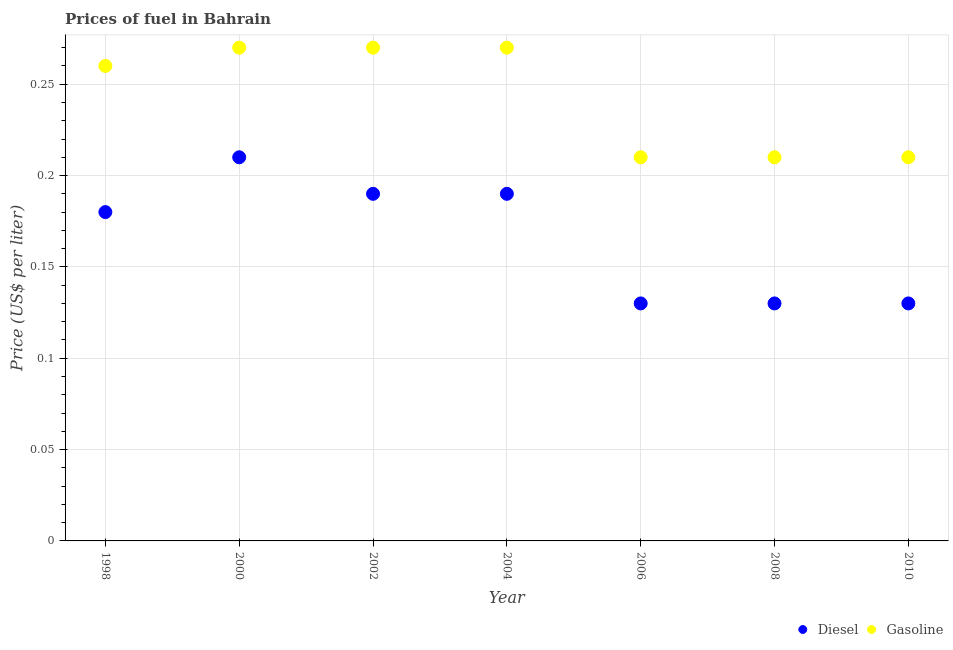Is the number of dotlines equal to the number of legend labels?
Offer a terse response. Yes. What is the diesel price in 2000?
Offer a terse response. 0.21. Across all years, what is the maximum diesel price?
Provide a short and direct response. 0.21. Across all years, what is the minimum diesel price?
Offer a very short reply. 0.13. In which year was the gasoline price maximum?
Your answer should be very brief. 2000. In which year was the gasoline price minimum?
Provide a short and direct response. 2006. What is the total diesel price in the graph?
Give a very brief answer. 1.16. What is the difference between the gasoline price in 2006 and the diesel price in 2008?
Offer a terse response. 0.08. What is the average diesel price per year?
Provide a succinct answer. 0.17. In the year 2006, what is the difference between the diesel price and gasoline price?
Keep it short and to the point. -0.08. In how many years, is the gasoline price greater than 0.04 US$ per litre?
Provide a succinct answer. 7. What is the ratio of the gasoline price in 2000 to that in 2010?
Keep it short and to the point. 1.29. Is the diesel price in 2004 less than that in 2010?
Give a very brief answer. No. Is the difference between the diesel price in 2006 and 2010 greater than the difference between the gasoline price in 2006 and 2010?
Your response must be concise. No. What is the difference between the highest and the second highest diesel price?
Your answer should be very brief. 0.02. What is the difference between the highest and the lowest diesel price?
Offer a terse response. 0.08. In how many years, is the diesel price greater than the average diesel price taken over all years?
Provide a short and direct response. 4. Does the gasoline price monotonically increase over the years?
Provide a short and direct response. No. Is the diesel price strictly greater than the gasoline price over the years?
Provide a short and direct response. No. Is the gasoline price strictly less than the diesel price over the years?
Ensure brevity in your answer.  No. How many dotlines are there?
Give a very brief answer. 2. How many years are there in the graph?
Ensure brevity in your answer.  7. What is the difference between two consecutive major ticks on the Y-axis?
Keep it short and to the point. 0.05. Are the values on the major ticks of Y-axis written in scientific E-notation?
Keep it short and to the point. No. Does the graph contain any zero values?
Provide a short and direct response. No. Does the graph contain grids?
Your answer should be compact. Yes. Where does the legend appear in the graph?
Keep it short and to the point. Bottom right. What is the title of the graph?
Give a very brief answer. Prices of fuel in Bahrain. Does "Age 65(male)" appear as one of the legend labels in the graph?
Offer a very short reply. No. What is the label or title of the Y-axis?
Offer a terse response. Price (US$ per liter). What is the Price (US$ per liter) in Diesel in 1998?
Offer a terse response. 0.18. What is the Price (US$ per liter) in Gasoline in 1998?
Ensure brevity in your answer.  0.26. What is the Price (US$ per liter) of Diesel in 2000?
Your answer should be compact. 0.21. What is the Price (US$ per liter) in Gasoline in 2000?
Give a very brief answer. 0.27. What is the Price (US$ per liter) of Diesel in 2002?
Your response must be concise. 0.19. What is the Price (US$ per liter) in Gasoline in 2002?
Give a very brief answer. 0.27. What is the Price (US$ per liter) of Diesel in 2004?
Your response must be concise. 0.19. What is the Price (US$ per liter) in Gasoline in 2004?
Your response must be concise. 0.27. What is the Price (US$ per liter) of Diesel in 2006?
Provide a short and direct response. 0.13. What is the Price (US$ per liter) in Gasoline in 2006?
Provide a succinct answer. 0.21. What is the Price (US$ per liter) in Diesel in 2008?
Offer a terse response. 0.13. What is the Price (US$ per liter) of Gasoline in 2008?
Provide a short and direct response. 0.21. What is the Price (US$ per liter) of Diesel in 2010?
Keep it short and to the point. 0.13. What is the Price (US$ per liter) in Gasoline in 2010?
Your answer should be very brief. 0.21. Across all years, what is the maximum Price (US$ per liter) of Diesel?
Your answer should be very brief. 0.21. Across all years, what is the maximum Price (US$ per liter) of Gasoline?
Make the answer very short. 0.27. Across all years, what is the minimum Price (US$ per liter) in Diesel?
Make the answer very short. 0.13. Across all years, what is the minimum Price (US$ per liter) in Gasoline?
Your answer should be compact. 0.21. What is the total Price (US$ per liter) of Diesel in the graph?
Your answer should be very brief. 1.16. What is the total Price (US$ per liter) in Gasoline in the graph?
Ensure brevity in your answer.  1.7. What is the difference between the Price (US$ per liter) of Diesel in 1998 and that in 2000?
Provide a succinct answer. -0.03. What is the difference between the Price (US$ per liter) in Gasoline in 1998 and that in 2000?
Your response must be concise. -0.01. What is the difference between the Price (US$ per liter) in Diesel in 1998 and that in 2002?
Provide a succinct answer. -0.01. What is the difference between the Price (US$ per liter) in Gasoline in 1998 and that in 2002?
Make the answer very short. -0.01. What is the difference between the Price (US$ per liter) in Diesel in 1998 and that in 2004?
Keep it short and to the point. -0.01. What is the difference between the Price (US$ per liter) of Gasoline in 1998 and that in 2004?
Offer a terse response. -0.01. What is the difference between the Price (US$ per liter) in Diesel in 1998 and that in 2006?
Offer a terse response. 0.05. What is the difference between the Price (US$ per liter) of Gasoline in 1998 and that in 2006?
Your response must be concise. 0.05. What is the difference between the Price (US$ per liter) of Diesel in 1998 and that in 2008?
Your response must be concise. 0.05. What is the difference between the Price (US$ per liter) of Gasoline in 1998 and that in 2010?
Your answer should be very brief. 0.05. What is the difference between the Price (US$ per liter) of Diesel in 2000 and that in 2004?
Make the answer very short. 0.02. What is the difference between the Price (US$ per liter) in Diesel in 2000 and that in 2006?
Provide a succinct answer. 0.08. What is the difference between the Price (US$ per liter) of Gasoline in 2000 and that in 2006?
Ensure brevity in your answer.  0.06. What is the difference between the Price (US$ per liter) of Gasoline in 2000 and that in 2008?
Your answer should be very brief. 0.06. What is the difference between the Price (US$ per liter) in Diesel in 2002 and that in 2004?
Give a very brief answer. 0. What is the difference between the Price (US$ per liter) of Gasoline in 2002 and that in 2006?
Ensure brevity in your answer.  0.06. What is the difference between the Price (US$ per liter) of Diesel in 2002 and that in 2010?
Offer a very short reply. 0.06. What is the difference between the Price (US$ per liter) of Diesel in 2004 and that in 2006?
Give a very brief answer. 0.06. What is the difference between the Price (US$ per liter) of Diesel in 2004 and that in 2008?
Your answer should be compact. 0.06. What is the difference between the Price (US$ per liter) in Gasoline in 2004 and that in 2010?
Make the answer very short. 0.06. What is the difference between the Price (US$ per liter) in Diesel in 2006 and that in 2010?
Ensure brevity in your answer.  0. What is the difference between the Price (US$ per liter) of Diesel in 2008 and that in 2010?
Your answer should be compact. 0. What is the difference between the Price (US$ per liter) of Gasoline in 2008 and that in 2010?
Offer a very short reply. 0. What is the difference between the Price (US$ per liter) in Diesel in 1998 and the Price (US$ per liter) in Gasoline in 2000?
Make the answer very short. -0.09. What is the difference between the Price (US$ per liter) of Diesel in 1998 and the Price (US$ per liter) of Gasoline in 2002?
Your answer should be very brief. -0.09. What is the difference between the Price (US$ per liter) in Diesel in 1998 and the Price (US$ per liter) in Gasoline in 2004?
Your answer should be very brief. -0.09. What is the difference between the Price (US$ per liter) in Diesel in 1998 and the Price (US$ per liter) in Gasoline in 2006?
Ensure brevity in your answer.  -0.03. What is the difference between the Price (US$ per liter) of Diesel in 1998 and the Price (US$ per liter) of Gasoline in 2008?
Your response must be concise. -0.03. What is the difference between the Price (US$ per liter) in Diesel in 1998 and the Price (US$ per liter) in Gasoline in 2010?
Ensure brevity in your answer.  -0.03. What is the difference between the Price (US$ per liter) of Diesel in 2000 and the Price (US$ per liter) of Gasoline in 2002?
Offer a terse response. -0.06. What is the difference between the Price (US$ per liter) in Diesel in 2000 and the Price (US$ per liter) in Gasoline in 2004?
Your response must be concise. -0.06. What is the difference between the Price (US$ per liter) in Diesel in 2000 and the Price (US$ per liter) in Gasoline in 2006?
Provide a short and direct response. 0. What is the difference between the Price (US$ per liter) of Diesel in 2000 and the Price (US$ per liter) of Gasoline in 2008?
Provide a short and direct response. 0. What is the difference between the Price (US$ per liter) of Diesel in 2000 and the Price (US$ per liter) of Gasoline in 2010?
Offer a terse response. 0. What is the difference between the Price (US$ per liter) in Diesel in 2002 and the Price (US$ per liter) in Gasoline in 2004?
Your response must be concise. -0.08. What is the difference between the Price (US$ per liter) of Diesel in 2002 and the Price (US$ per liter) of Gasoline in 2006?
Your answer should be compact. -0.02. What is the difference between the Price (US$ per liter) of Diesel in 2002 and the Price (US$ per liter) of Gasoline in 2008?
Provide a short and direct response. -0.02. What is the difference between the Price (US$ per liter) in Diesel in 2002 and the Price (US$ per liter) in Gasoline in 2010?
Keep it short and to the point. -0.02. What is the difference between the Price (US$ per liter) of Diesel in 2004 and the Price (US$ per liter) of Gasoline in 2006?
Give a very brief answer. -0.02. What is the difference between the Price (US$ per liter) of Diesel in 2004 and the Price (US$ per liter) of Gasoline in 2008?
Your answer should be very brief. -0.02. What is the difference between the Price (US$ per liter) of Diesel in 2004 and the Price (US$ per liter) of Gasoline in 2010?
Offer a very short reply. -0.02. What is the difference between the Price (US$ per liter) of Diesel in 2006 and the Price (US$ per liter) of Gasoline in 2008?
Ensure brevity in your answer.  -0.08. What is the difference between the Price (US$ per liter) in Diesel in 2006 and the Price (US$ per liter) in Gasoline in 2010?
Ensure brevity in your answer.  -0.08. What is the difference between the Price (US$ per liter) of Diesel in 2008 and the Price (US$ per liter) of Gasoline in 2010?
Your answer should be compact. -0.08. What is the average Price (US$ per liter) in Diesel per year?
Your answer should be very brief. 0.17. What is the average Price (US$ per liter) in Gasoline per year?
Your response must be concise. 0.24. In the year 1998, what is the difference between the Price (US$ per liter) of Diesel and Price (US$ per liter) of Gasoline?
Ensure brevity in your answer.  -0.08. In the year 2000, what is the difference between the Price (US$ per liter) in Diesel and Price (US$ per liter) in Gasoline?
Offer a terse response. -0.06. In the year 2002, what is the difference between the Price (US$ per liter) in Diesel and Price (US$ per liter) in Gasoline?
Provide a succinct answer. -0.08. In the year 2004, what is the difference between the Price (US$ per liter) of Diesel and Price (US$ per liter) of Gasoline?
Make the answer very short. -0.08. In the year 2006, what is the difference between the Price (US$ per liter) in Diesel and Price (US$ per liter) in Gasoline?
Your answer should be compact. -0.08. In the year 2008, what is the difference between the Price (US$ per liter) of Diesel and Price (US$ per liter) of Gasoline?
Ensure brevity in your answer.  -0.08. In the year 2010, what is the difference between the Price (US$ per liter) in Diesel and Price (US$ per liter) in Gasoline?
Your answer should be compact. -0.08. What is the ratio of the Price (US$ per liter) in Gasoline in 1998 to that in 2000?
Ensure brevity in your answer.  0.96. What is the ratio of the Price (US$ per liter) of Diesel in 1998 to that in 2002?
Ensure brevity in your answer.  0.95. What is the ratio of the Price (US$ per liter) of Gasoline in 1998 to that in 2002?
Provide a short and direct response. 0.96. What is the ratio of the Price (US$ per liter) in Diesel in 1998 to that in 2004?
Your answer should be very brief. 0.95. What is the ratio of the Price (US$ per liter) in Diesel in 1998 to that in 2006?
Ensure brevity in your answer.  1.38. What is the ratio of the Price (US$ per liter) in Gasoline in 1998 to that in 2006?
Your answer should be compact. 1.24. What is the ratio of the Price (US$ per liter) of Diesel in 1998 to that in 2008?
Your answer should be very brief. 1.38. What is the ratio of the Price (US$ per liter) of Gasoline in 1998 to that in 2008?
Provide a short and direct response. 1.24. What is the ratio of the Price (US$ per liter) of Diesel in 1998 to that in 2010?
Provide a succinct answer. 1.38. What is the ratio of the Price (US$ per liter) in Gasoline in 1998 to that in 2010?
Provide a short and direct response. 1.24. What is the ratio of the Price (US$ per liter) in Diesel in 2000 to that in 2002?
Offer a terse response. 1.11. What is the ratio of the Price (US$ per liter) of Gasoline in 2000 to that in 2002?
Offer a terse response. 1. What is the ratio of the Price (US$ per liter) of Diesel in 2000 to that in 2004?
Your response must be concise. 1.11. What is the ratio of the Price (US$ per liter) of Diesel in 2000 to that in 2006?
Your answer should be very brief. 1.62. What is the ratio of the Price (US$ per liter) in Gasoline in 2000 to that in 2006?
Provide a short and direct response. 1.29. What is the ratio of the Price (US$ per liter) of Diesel in 2000 to that in 2008?
Offer a terse response. 1.62. What is the ratio of the Price (US$ per liter) in Diesel in 2000 to that in 2010?
Your answer should be very brief. 1.62. What is the ratio of the Price (US$ per liter) of Gasoline in 2000 to that in 2010?
Give a very brief answer. 1.29. What is the ratio of the Price (US$ per liter) of Gasoline in 2002 to that in 2004?
Make the answer very short. 1. What is the ratio of the Price (US$ per liter) of Diesel in 2002 to that in 2006?
Your answer should be compact. 1.46. What is the ratio of the Price (US$ per liter) of Diesel in 2002 to that in 2008?
Give a very brief answer. 1.46. What is the ratio of the Price (US$ per liter) of Gasoline in 2002 to that in 2008?
Provide a succinct answer. 1.29. What is the ratio of the Price (US$ per liter) of Diesel in 2002 to that in 2010?
Give a very brief answer. 1.46. What is the ratio of the Price (US$ per liter) of Diesel in 2004 to that in 2006?
Ensure brevity in your answer.  1.46. What is the ratio of the Price (US$ per liter) in Gasoline in 2004 to that in 2006?
Ensure brevity in your answer.  1.29. What is the ratio of the Price (US$ per liter) in Diesel in 2004 to that in 2008?
Your answer should be compact. 1.46. What is the ratio of the Price (US$ per liter) of Gasoline in 2004 to that in 2008?
Ensure brevity in your answer.  1.29. What is the ratio of the Price (US$ per liter) in Diesel in 2004 to that in 2010?
Keep it short and to the point. 1.46. What is the ratio of the Price (US$ per liter) of Diesel in 2006 to that in 2008?
Your answer should be compact. 1. What is the ratio of the Price (US$ per liter) of Gasoline in 2006 to that in 2010?
Keep it short and to the point. 1. 